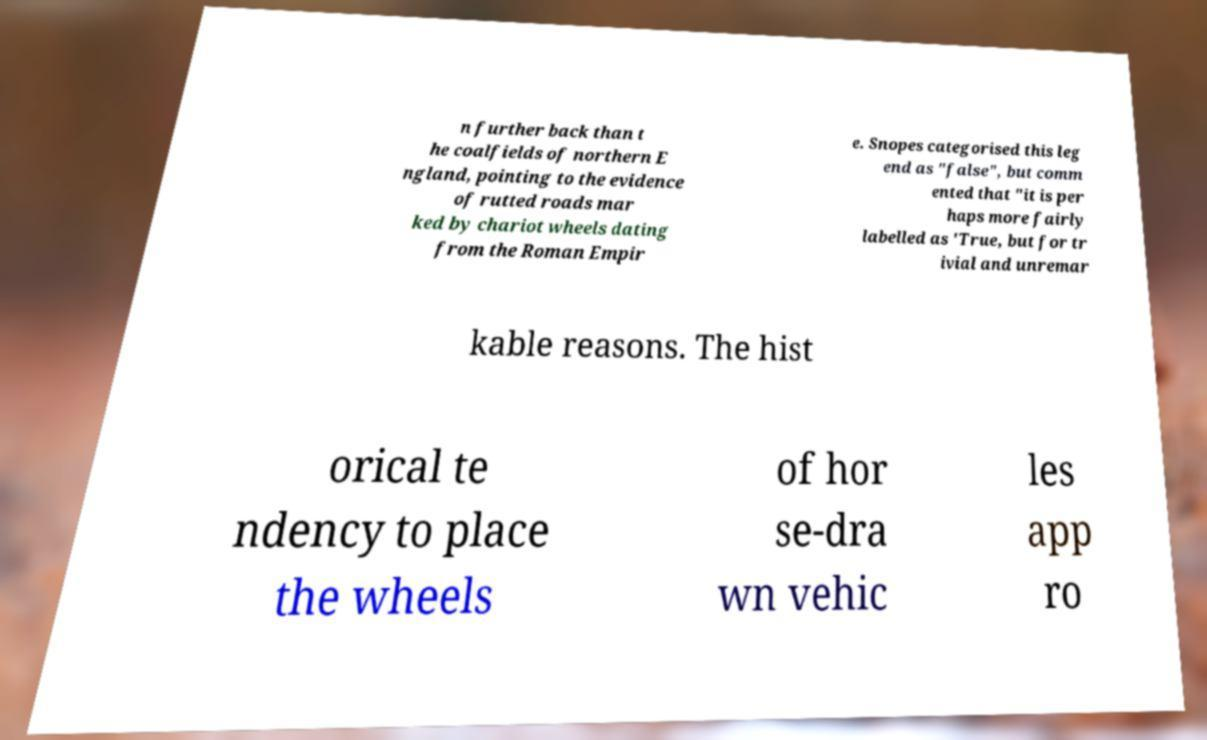Could you assist in decoding the text presented in this image and type it out clearly? n further back than t he coalfields of northern E ngland, pointing to the evidence of rutted roads mar ked by chariot wheels dating from the Roman Empir e. Snopes categorised this leg end as "false", but comm ented that "it is per haps more fairly labelled as 'True, but for tr ivial and unremar kable reasons. The hist orical te ndency to place the wheels of hor se-dra wn vehic les app ro 